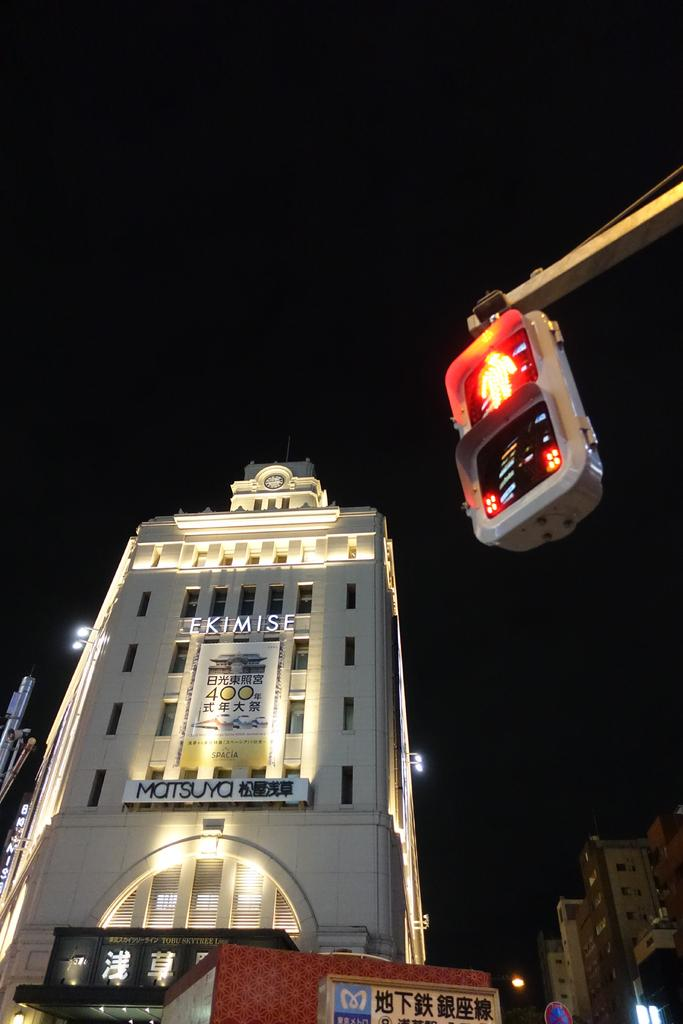<image>
Describe the image concisely. an exterior of the EKimise building with ad for Matsuya 